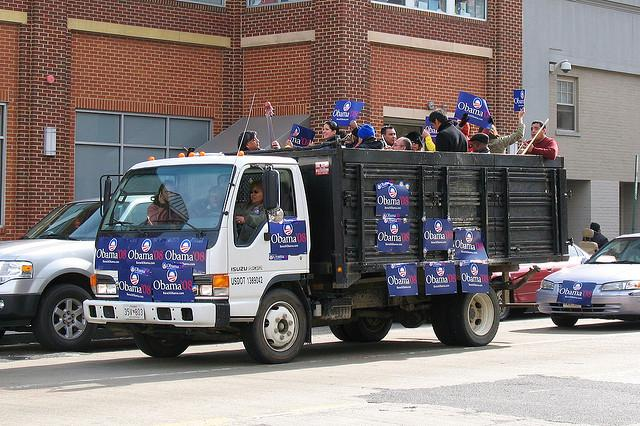Who did they want to be Vice President? Please explain your reasoning. biden. The current us president was obama's running mate in 2008. 